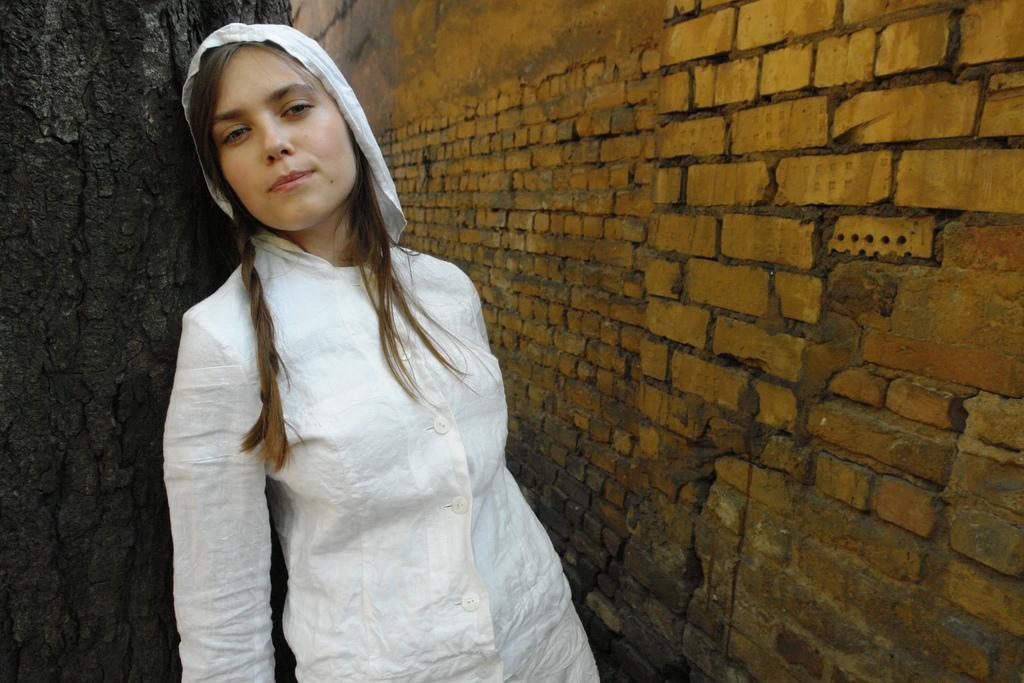Can you describe this image briefly? In this image we can see a lady. On the right side there is a brick wall. She is leaning to a wood. 